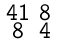Convert formula to latex. <formula><loc_0><loc_0><loc_500><loc_500>\begin{smallmatrix} 4 1 & 8 \\ 8 & 4 \end{smallmatrix}</formula> 